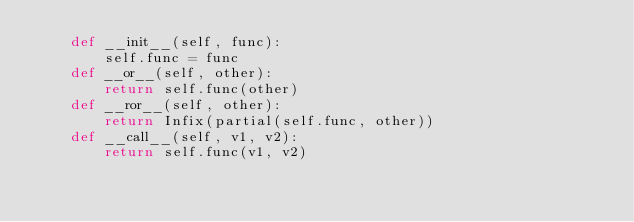Convert code to text. <code><loc_0><loc_0><loc_500><loc_500><_Python_>    def __init__(self, func):
        self.func = func
    def __or__(self, other):
        return self.func(other)
    def __ror__(self, other):
        return Infix(partial(self.func, other))
    def __call__(self, v1, v2):
        return self.func(v1, v2)</code> 